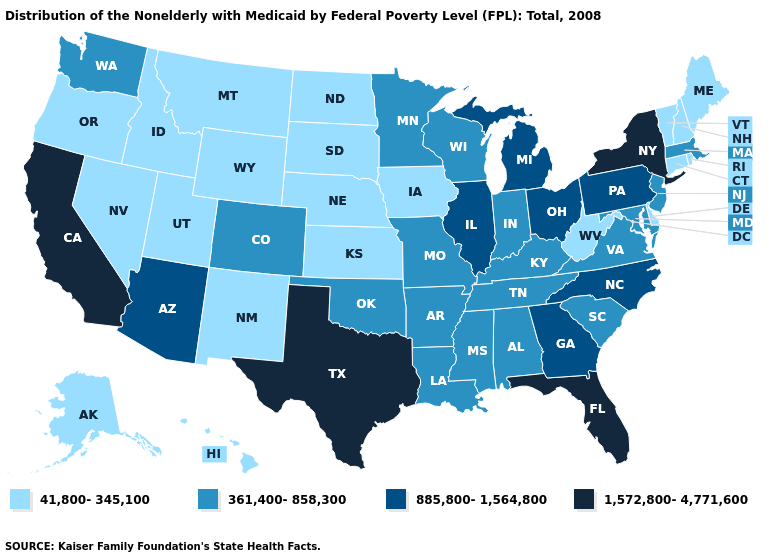What is the value of Nevada?
Quick response, please. 41,800-345,100. Name the states that have a value in the range 361,400-858,300?
Short answer required. Alabama, Arkansas, Colorado, Indiana, Kentucky, Louisiana, Maryland, Massachusetts, Minnesota, Mississippi, Missouri, New Jersey, Oklahoma, South Carolina, Tennessee, Virginia, Washington, Wisconsin. Name the states that have a value in the range 41,800-345,100?
Keep it brief. Alaska, Connecticut, Delaware, Hawaii, Idaho, Iowa, Kansas, Maine, Montana, Nebraska, Nevada, New Hampshire, New Mexico, North Dakota, Oregon, Rhode Island, South Dakota, Utah, Vermont, West Virginia, Wyoming. Among the states that border California , does Arizona have the lowest value?
Be succinct. No. What is the value of South Dakota?
Keep it brief. 41,800-345,100. Name the states that have a value in the range 41,800-345,100?
Short answer required. Alaska, Connecticut, Delaware, Hawaii, Idaho, Iowa, Kansas, Maine, Montana, Nebraska, Nevada, New Hampshire, New Mexico, North Dakota, Oregon, Rhode Island, South Dakota, Utah, Vermont, West Virginia, Wyoming. Name the states that have a value in the range 1,572,800-4,771,600?
Short answer required. California, Florida, New York, Texas. Does California have the highest value in the West?
Short answer required. Yes. What is the highest value in the Northeast ?
Quick response, please. 1,572,800-4,771,600. What is the value of Ohio?
Quick response, please. 885,800-1,564,800. Name the states that have a value in the range 361,400-858,300?
Concise answer only. Alabama, Arkansas, Colorado, Indiana, Kentucky, Louisiana, Maryland, Massachusetts, Minnesota, Mississippi, Missouri, New Jersey, Oklahoma, South Carolina, Tennessee, Virginia, Washington, Wisconsin. Among the states that border Minnesota , which have the lowest value?
Short answer required. Iowa, North Dakota, South Dakota. Is the legend a continuous bar?
Answer briefly. No. Does the first symbol in the legend represent the smallest category?
Write a very short answer. Yes. Among the states that border Mississippi , which have the lowest value?
Keep it brief. Alabama, Arkansas, Louisiana, Tennessee. 